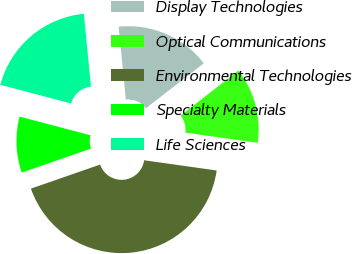Convert chart to OTSL. <chart><loc_0><loc_0><loc_500><loc_500><pie_chart><fcel>Display Technologies<fcel>Optical Communications<fcel>Environmental Technologies<fcel>Specialty Materials<fcel>Life Sciences<nl><fcel>16.04%<fcel>12.74%<fcel>42.45%<fcel>9.43%<fcel>19.34%<nl></chart> 